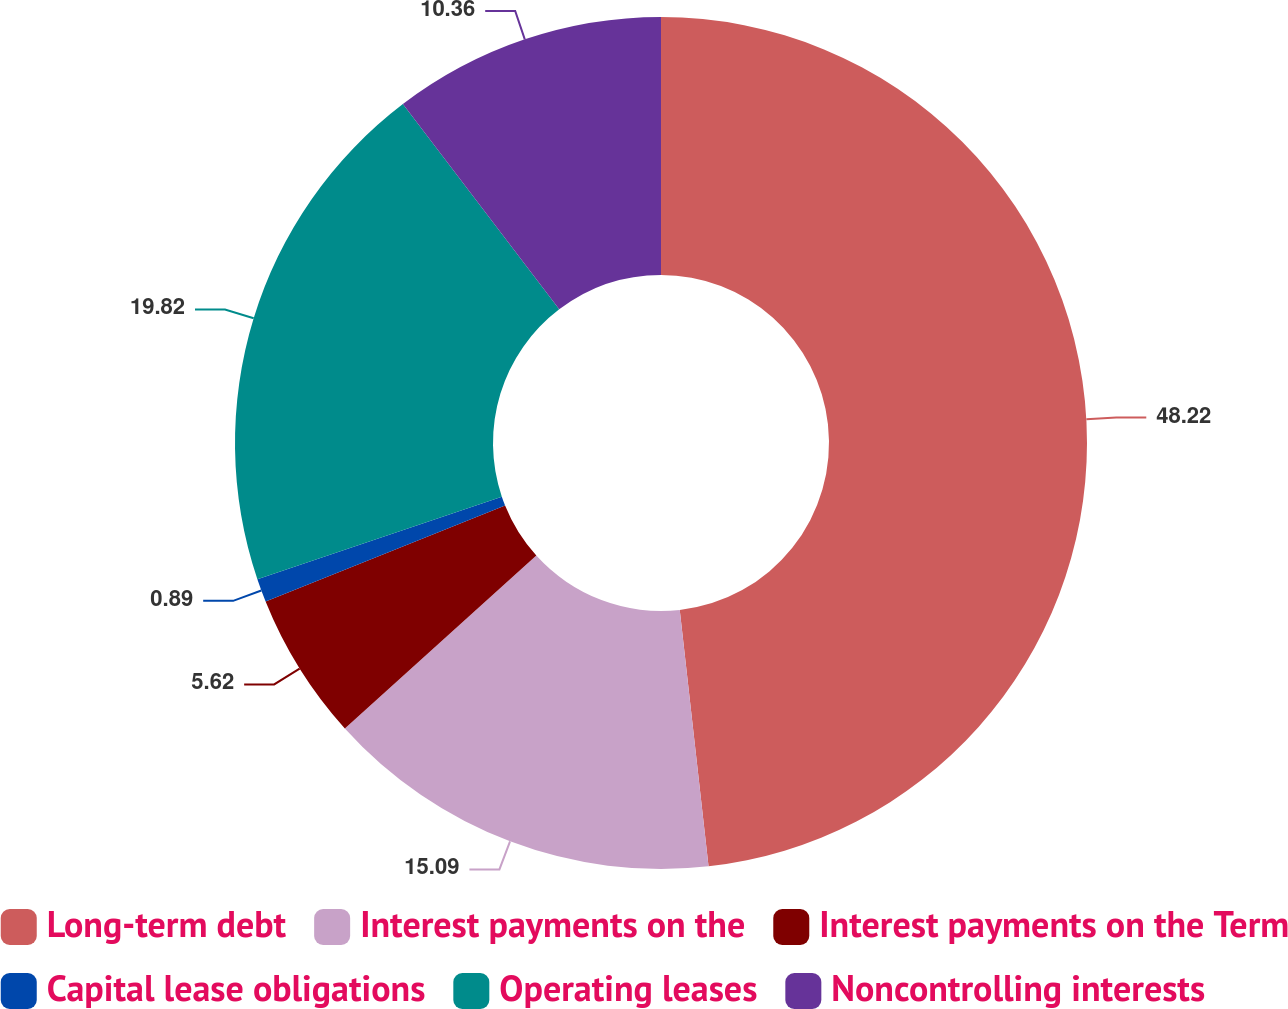<chart> <loc_0><loc_0><loc_500><loc_500><pie_chart><fcel>Long-term debt<fcel>Interest payments on the<fcel>Interest payments on the Term<fcel>Capital lease obligations<fcel>Operating leases<fcel>Noncontrolling interests<nl><fcel>48.22%<fcel>15.09%<fcel>5.62%<fcel>0.89%<fcel>19.82%<fcel>10.36%<nl></chart> 